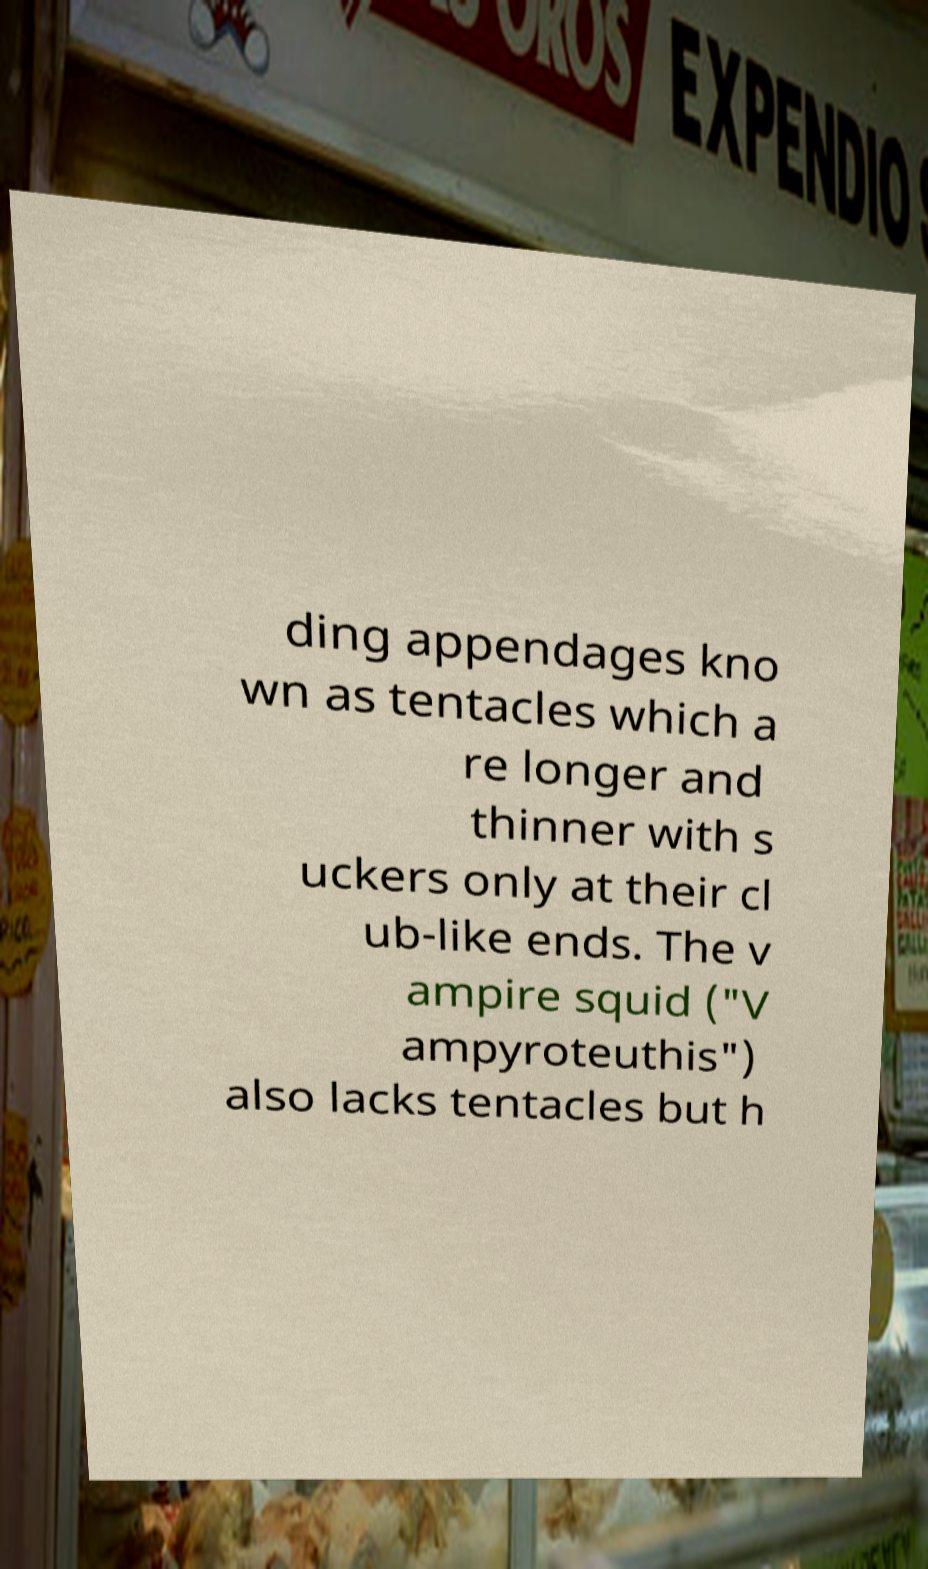Can you accurately transcribe the text from the provided image for me? ding appendages kno wn as tentacles which a re longer and thinner with s uckers only at their cl ub-like ends. The v ampire squid ("V ampyroteuthis") also lacks tentacles but h 